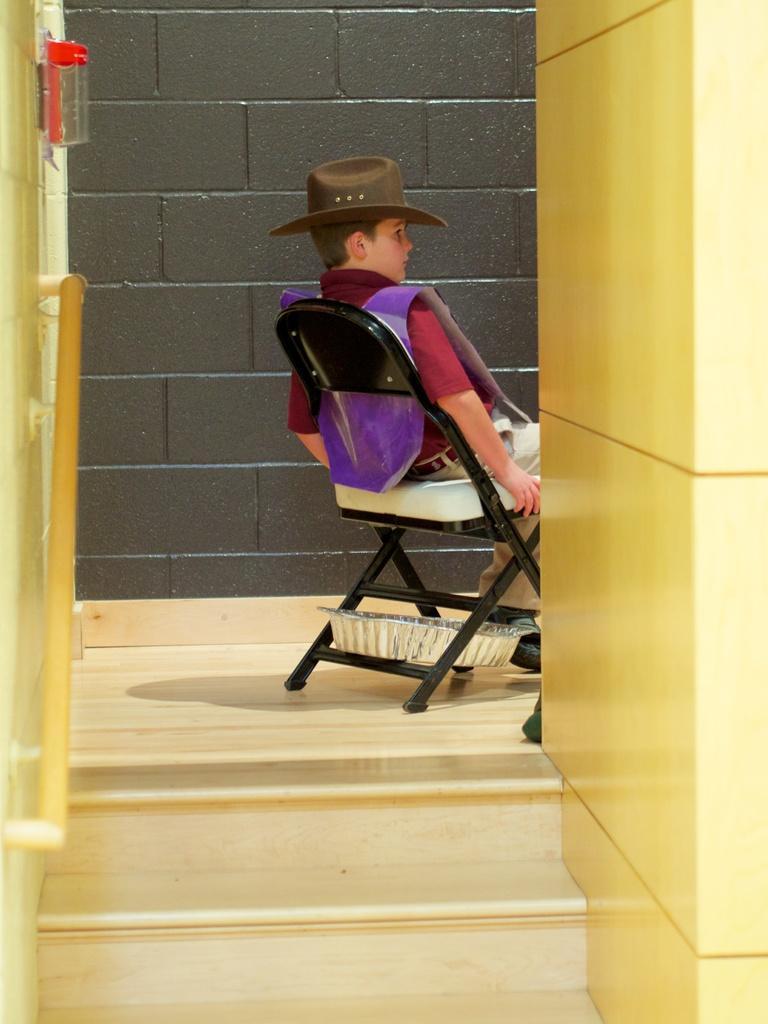Could you give a brief overview of what you see in this image? In this image i can see a boy sitting on a chair and 2 stairs. In the background i can see a wall made of bricks. 